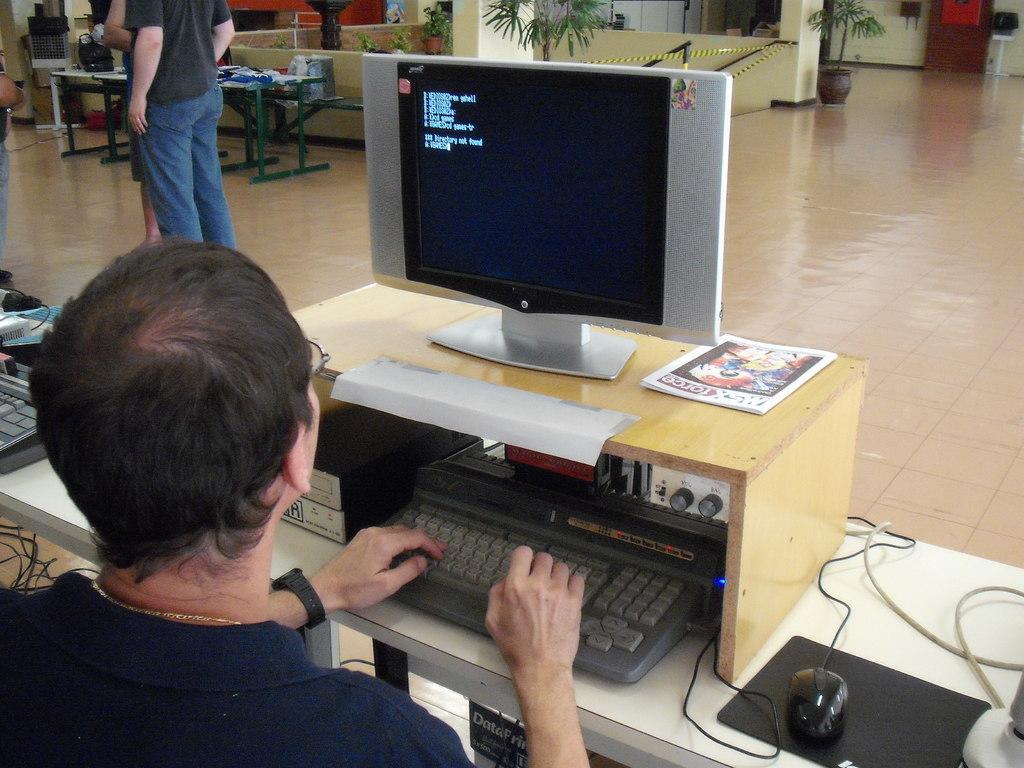In one or two sentences, can you explain what this image depicts? This is the man sitting and working. This is the table with the mouse,keyboard,cables,mouse pad few other objects. This is a monitor placed on the wooden rack. Here is the magazine beside the monitor. I can see two people standing. At the background I can see another table with few objects on it. This is a houseplant. At background this looks like a door. I can see a white color object which looks like a table. I think these are the staircase holder attached to the wall. this is the floor. 